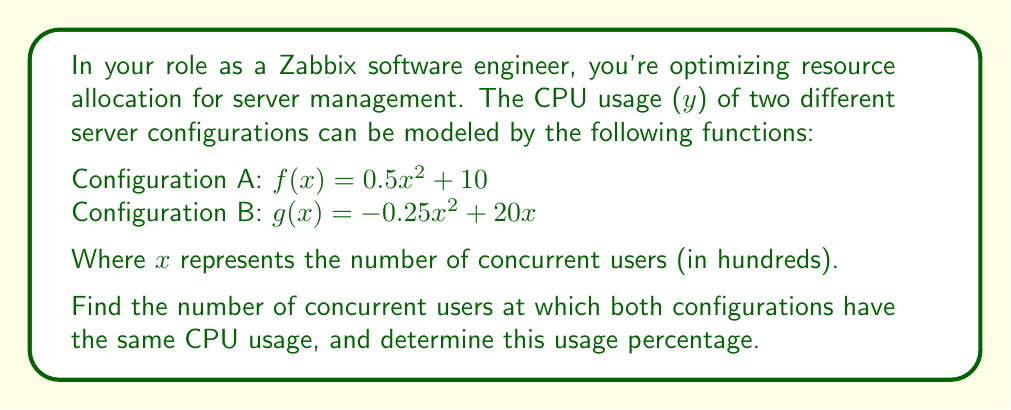Solve this math problem. To find the intersection of the two functions, we need to solve the equation $f(x) = g(x)$:

1) Set up the equation:
   $0.5x^2 + 10 = -0.25x^2 + 20x$

2) Rearrange terms:
   $0.5x^2 + 0.25x^2 = 20x - 10$
   $0.75x^2 = 20x - 10$

3) Subtract 20x from both sides:
   $0.75x^2 - 20x = -10$

4) Add 10 to both sides:
   $0.75x^2 - 20x + 10 = 0$

5) Multiply all terms by 4 to simplify coefficients:
   $3x^2 - 80x + 40 = 0$

6) This is a quadratic equation. We can solve it using the quadratic formula:
   $x = \frac{-b \pm \sqrt{b^2 - 4ac}}{2a}$

   Where $a = 3$, $b = -80$, and $c = 40$

7) Substitute these values:
   $x = \frac{80 \pm \sqrt{(-80)^2 - 4(3)(40)}}{2(3)}$
   $x = \frac{80 \pm \sqrt{6400 - 480}}{6}$
   $x = \frac{80 \pm \sqrt{5920}}{6}$
   $x = \frac{80 \pm 76.94}{6}$

8) This gives us two solutions:
   $x_1 = \frac{80 + 76.94}{6} \approx 26.16$
   $x_2 = \frac{80 - 76.94}{6} \approx 0.51$

9) Since we're dealing with concurrent users, we'll use the positive solution: $x \approx 26.16$

10) To find the CPU usage at this point, we can substitute this x-value into either function:
    $f(26.16) = 0.5(26.16)^2 + 10 \approx 352.17$

Therefore, the configurations have the same CPU usage when there are approximately 2,616 concurrent users (26.16 hundreds), and the CPU usage at this point is about 352.17%.
Answer: 2,616 users; 352.17% CPU usage 